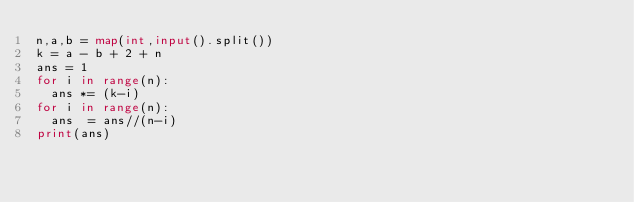<code> <loc_0><loc_0><loc_500><loc_500><_Python_>n,a,b = map(int,input().split())
k = a - b + 2 + n
ans = 1
for i in range(n):
  ans *= (k-i)
for i in range(n):
  ans  = ans//(n-i)
print(ans)
  
</code> 